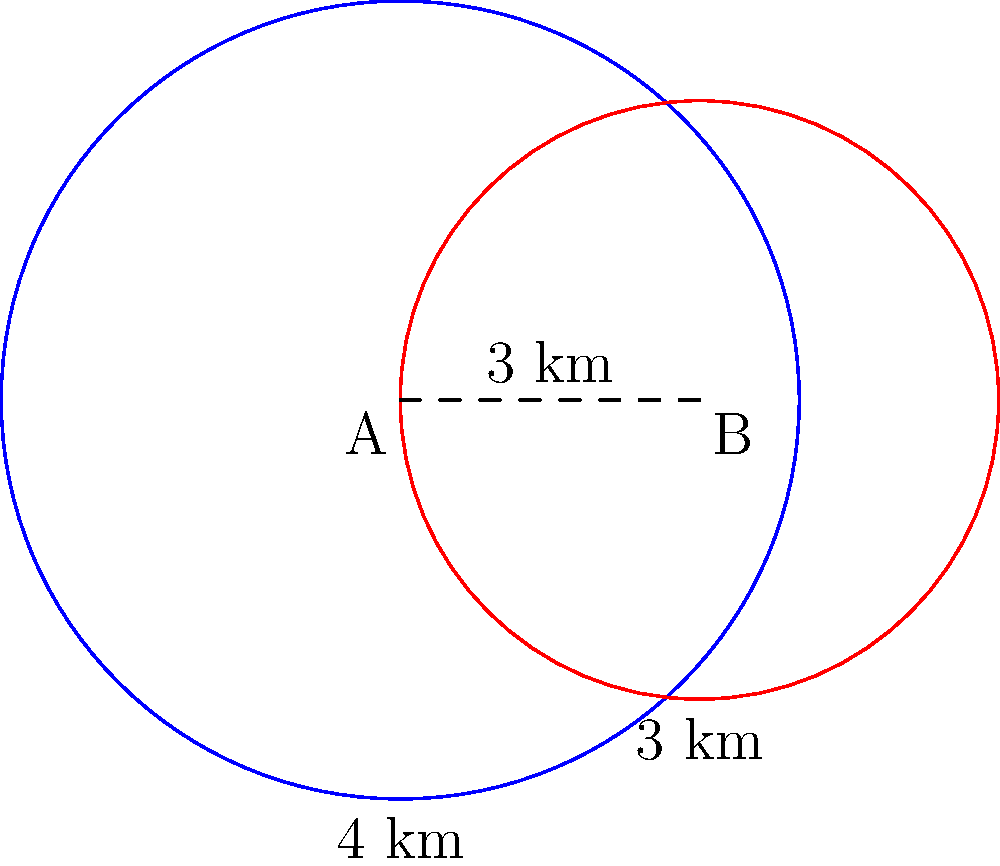As an NGO director, you're planning two outreach programs in neighboring cities. The circular coverage areas of these programs are shown in the diagram, with radii of 4 km and 3 km, and their centers 3 km apart. To optimize resource allocation, you need to calculate the area of overlap between these two coverage zones. What is the area of the overlapping region, rounded to the nearest square kilometer? Let's approach this step-by-step:

1) First, we need to recall the formula for the area of overlap between two circles. This is given by:

   $$A = r_1^2 \arccos(\frac{d^2 + r_1^2 - r_2^2}{2dr_1}) + r_2^2 \arccos(\frac{d^2 + r_2^2 - r_1^2}{2dr_2}) - \frac{1}{2}\sqrt{(-d+r_1+r_2)(d+r_1-r_2)(d-r_1+r_2)(d+r_1+r_2)}$$

   Where $r_1$ and $r_2$ are the radii of the circles, and $d$ is the distance between their centers.

2) In our case:
   $r_1 = 4$ km
   $r_2 = 3$ km
   $d = 3$ km

3) Let's substitute these values into our formula:

   $$A = 4^2 \arccos(\frac{3^2 + 4^2 - 3^2}{2 \cdot 3 \cdot 4}) + 3^2 \arccos(\frac{3^2 + 3^2 - 4^2}{2 \cdot 3 \cdot 3}) - \frac{1}{2}\sqrt{(-3+4+3)(3+4-3)(3-4+3)(3+4+3)}$$

4) Simplifying inside the arccos functions:

   $$A = 16 \arccos(\frac{25}{24}) + 9 \arccos(\frac{10}{18}) - \frac{1}{2}\sqrt{4 \cdot 4 \cdot 2 \cdot 10}$$

5) Calculating the arccos values and the square root:

   $$A = 16 \cdot 0.2933 + 9 \cdot 1.0472 - \frac{1}{2}\sqrt{320}$$

6) Simplifying:

   $$A = 4.6928 + 9.4248 - 8.9443 = 5.1733$$

7) Rounding to the nearest square kilometer:

   $$A \approx 5 \text{ km}^2$$
Answer: 5 km² 